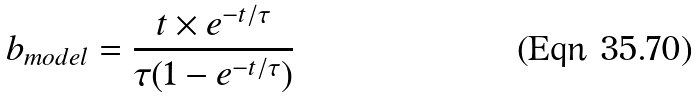<formula> <loc_0><loc_0><loc_500><loc_500>b _ { m o d e l } = \frac { t \times e ^ { - t / \tau } } { \tau ( 1 - e ^ { - t / \tau } ) }</formula> 